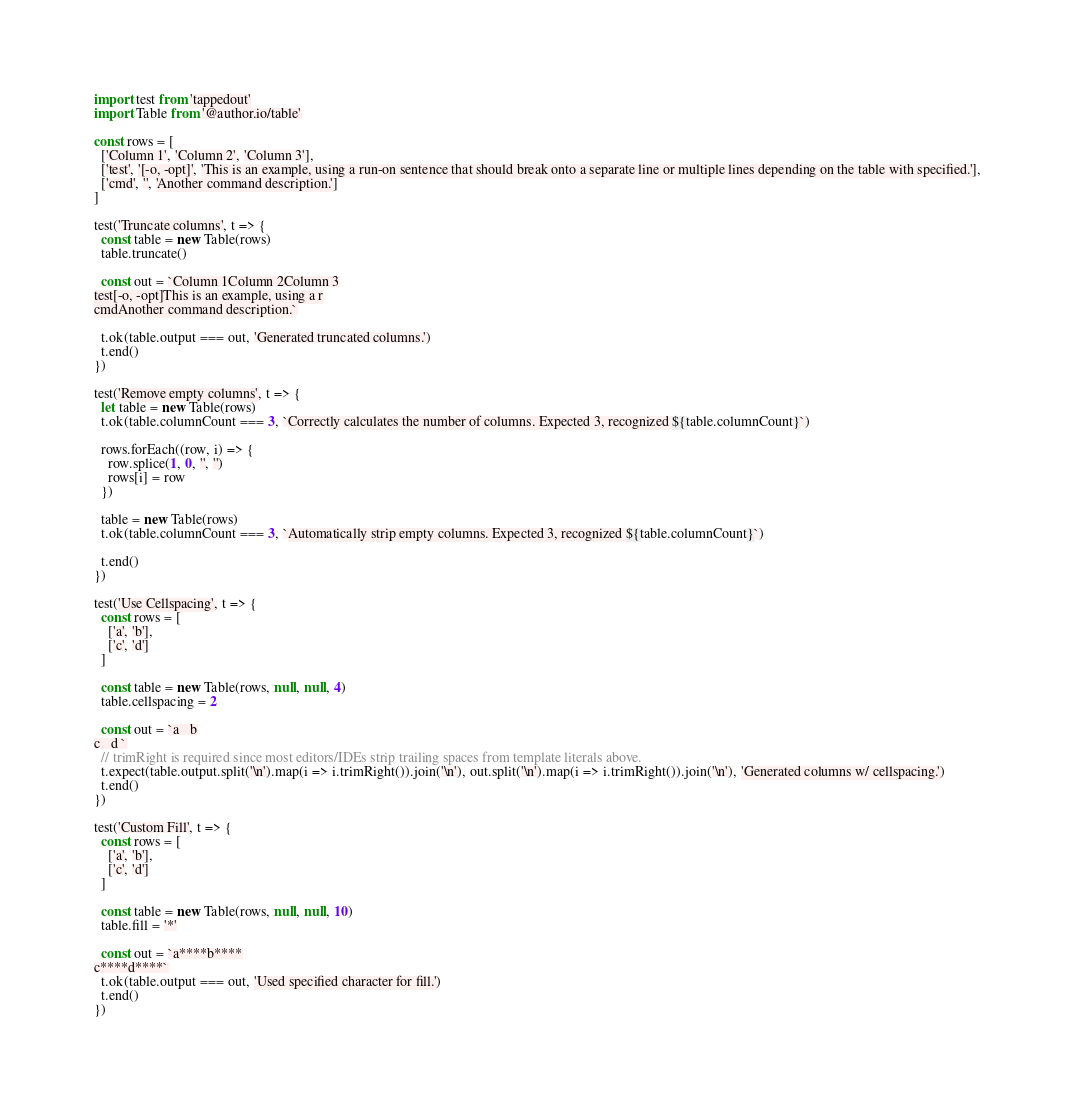<code> <loc_0><loc_0><loc_500><loc_500><_JavaScript_>import test from 'tappedout'
import Table from '@author.io/table'

const rows = [
  ['Column 1', 'Column 2', 'Column 3'],
  ['test', '[-o, -opt]', 'This is an example, using a run-on sentence that should break onto a separate line or multiple lines depending on the table with specified.'],
  ['cmd', '', 'Another command description.']
]

test('Truncate columns', t => {
  const table = new Table(rows)
  table.truncate()

  const out = `Column 1Column 2Column 3
test[-o, -opt]This is an example, using a r
cmdAnother command description.`

  t.ok(table.output === out, 'Generated truncated columns.')
  t.end()
})

test('Remove empty columns', t => {
  let table = new Table(rows)
  t.ok(table.columnCount === 3, `Correctly calculates the number of columns. Expected 3, recognized ${table.columnCount}`)

  rows.forEach((row, i) => {
    row.splice(1, 0, '', '')
    rows[i] = row
  })

  table = new Table(rows)
  t.ok(table.columnCount === 3, `Automatically strip empty columns. Expected 3, recognized ${table.columnCount}`)

  t.end()
})

test('Use Cellspacing', t => {
  const rows = [
    ['a', 'b'],
    ['c', 'd']
  ]

  const table = new Table(rows, null, null, 4)
  table.cellspacing = 2

  const out = `a   b
c   d `
  // trimRight is required since most editors/IDEs strip trailing spaces from template literals above.
  t.expect(table.output.split('\n').map(i => i.trimRight()).join('\n'), out.split('\n').map(i => i.trimRight()).join('\n'), 'Generated columns w/ cellspacing.')
  t.end()
})

test('Custom Fill', t => {
  const rows = [
    ['a', 'b'],
    ['c', 'd']
  ]

  const table = new Table(rows, null, null, 10)
  table.fill = '*'

  const out = `a****b****
c****d****`
  t.ok(table.output === out, 'Used specified character for fill.')
  t.end()
})
</code> 